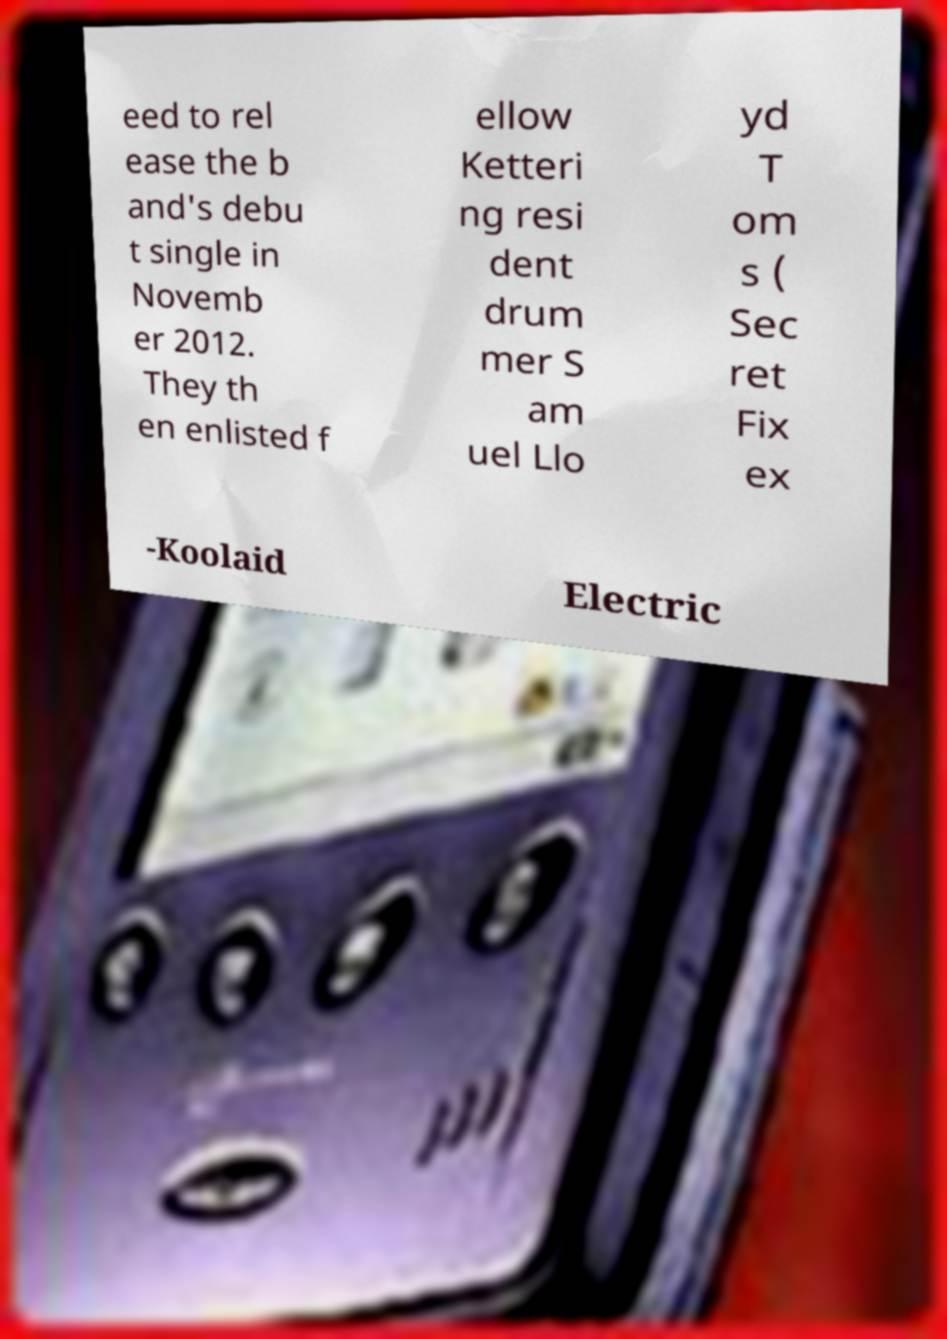Please identify and transcribe the text found in this image. eed to rel ease the b and's debu t single in Novemb er 2012. They th en enlisted f ellow Ketteri ng resi dent drum mer S am uel Llo yd T om s ( Sec ret Fix ex -Koolaid Electric 